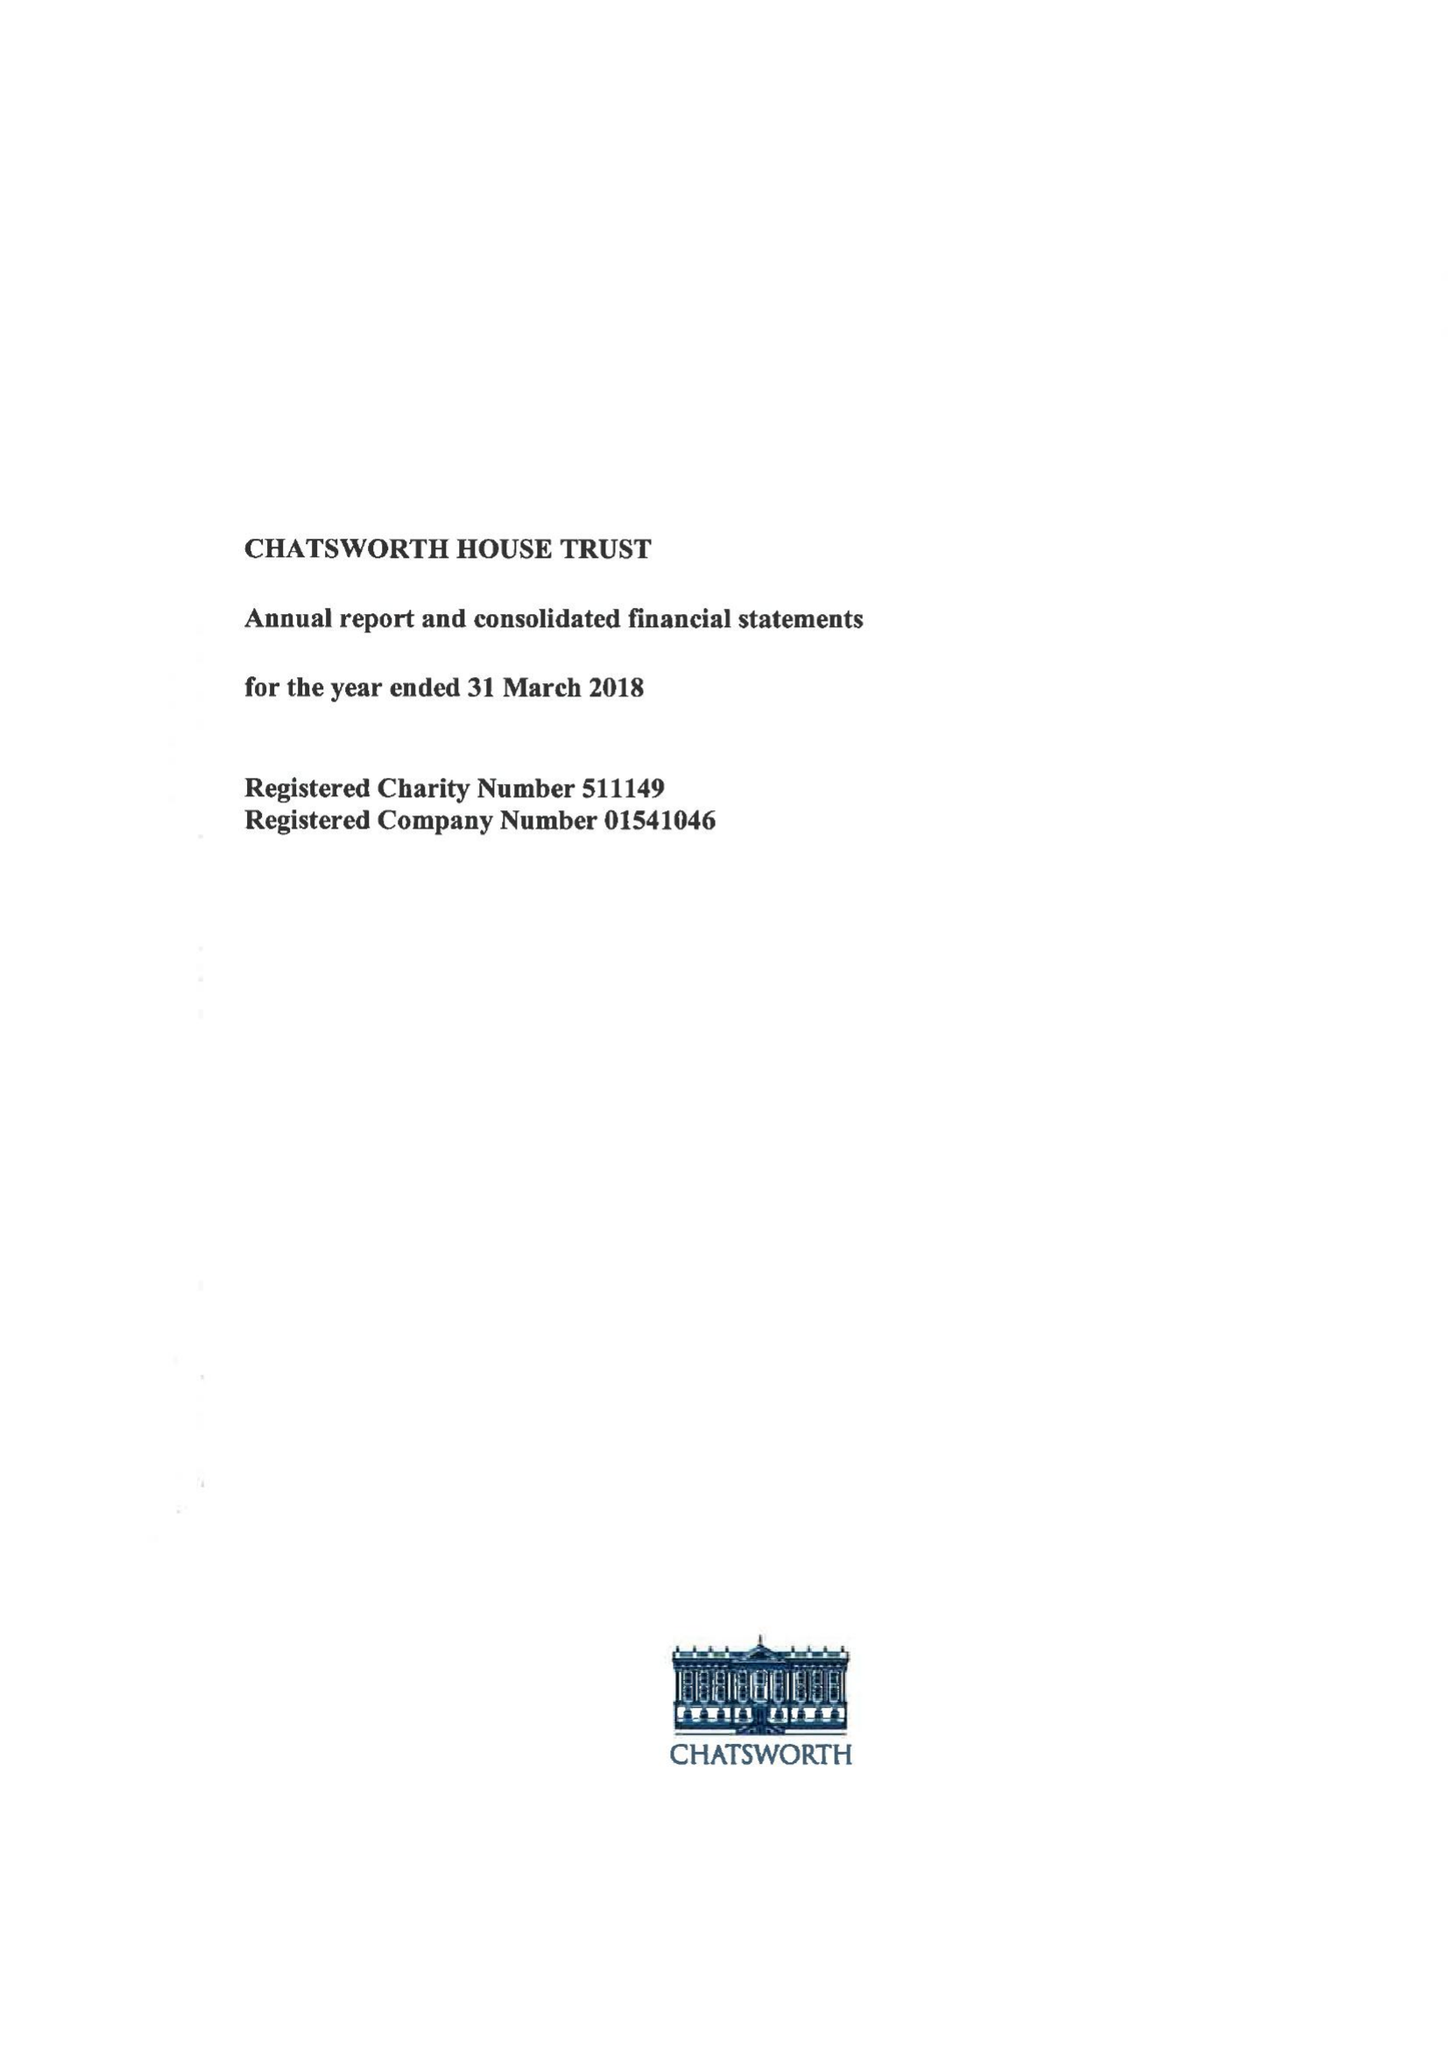What is the value for the charity_number?
Answer the question using a single word or phrase. 511149 